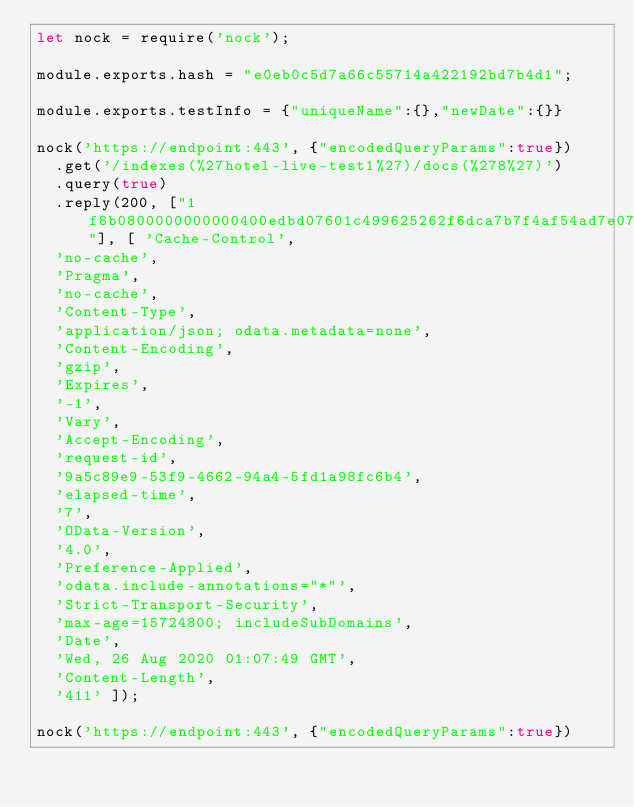Convert code to text. <code><loc_0><loc_0><loc_500><loc_500><_JavaScript_>let nock = require('nock');

module.exports.hash = "e0eb0c5d7a66c55714a422192bd7b4d1";

module.exports.testInfo = {"uniqueName":{},"newDate":{}}

nock('https://endpoint:443', {"encodedQueryParams":true})
  .get('/indexes(%27hotel-live-test1%27)/docs(%278%27)')
  .query(true)
  .reply(200, ["1f8b0800000000000400edbd07601c499625262f6dca7b7f4af54ad7e074a10880601324d8904010ecc188cde692ec1d69472329ab2a81ca6556655d661640cced9dbcf7de7befbdf7de7befbdf7ba3b9d4e27f7dfff3f5c6664016cf6ce4adac99e2180aac81f3f7e7c1f3f227ef147f3aacdcbb3d9478f3e3af868247fbdc816f9478f96ebb21c7d34cb9b695dacdaa25a52936f674dda548b3cadab6c962eaba2c9d36c394b8b265de6efdab4add2769ea797797d9daeaab298e669d36678799c3ec9da795d558b269dd3bb8baacecb745a51d36279d18ca96fafab6735757656a6d76996ced6e9a45e176d3acbd332a39ed76d9ee66d4a5db7f4c7659efebeeb9d9d7c279de2e7f97e8b1ff9436daedde32f41689c3ecf69105959d20ffa749215cb34bbcc8a7c892e9ab4ce2f1942d6e60bfa8c1b11b6055e009a53fae2a2aaaf0d85daeca2f9e8d1f7be3ffa6895d56f693067cb69b99ee5445269d02c2a7c7c5c96d595fbb4cc9af655beac2e19bfa704d47c53d327cb0bf357595187d4c2fc9dcd6675de508ff2275314ddff92ff07355dccd3cb010000"], [ 'Cache-Control',
  'no-cache',
  'Pragma',
  'no-cache',
  'Content-Type',
  'application/json; odata.metadata=none',
  'Content-Encoding',
  'gzip',
  'Expires',
  '-1',
  'Vary',
  'Accept-Encoding',
  'request-id',
  '9a5c89e9-53f9-4662-94a4-5fd1a98fc6b4',
  'elapsed-time',
  '7',
  'OData-Version',
  '4.0',
  'Preference-Applied',
  'odata.include-annotations="*"',
  'Strict-Transport-Security',
  'max-age=15724800; includeSubDomains',
  'Date',
  'Wed, 26 Aug 2020 01:07:49 GMT',
  'Content-Length',
  '411' ]);

nock('https://endpoint:443', {"encodedQueryParams":true})</code> 